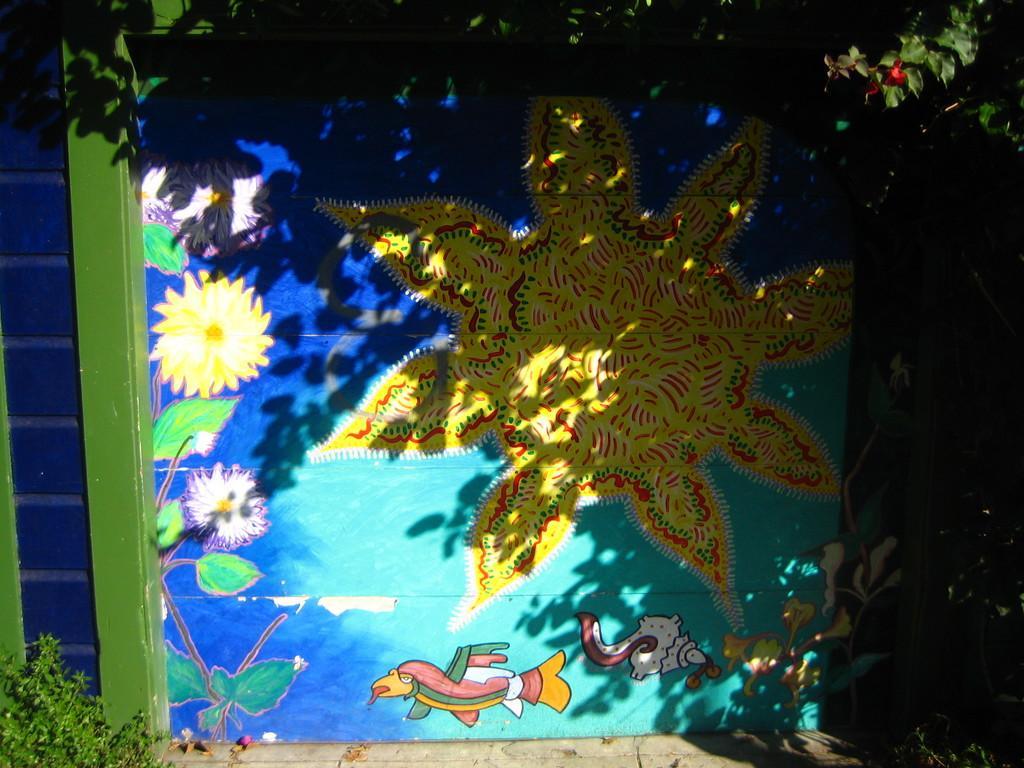In one or two sentences, can you explain what this image depicts? In this image I can see the blue and green colored wall on which can see the painting which is yellow, green , white , red and blue in color. I can see the ground and few trees. 